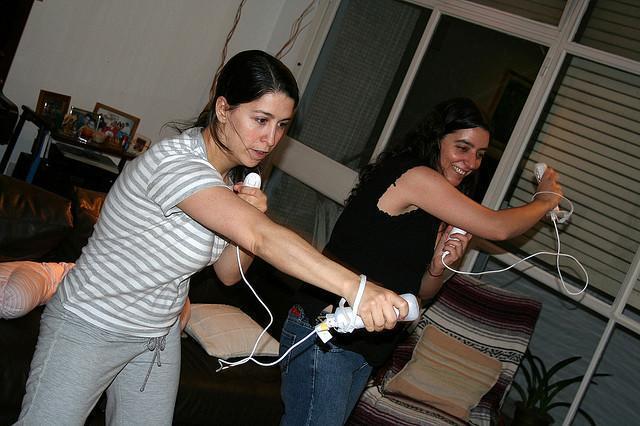How many people are there?
Give a very brief answer. 2. How many remotes are there?
Give a very brief answer. 1. 